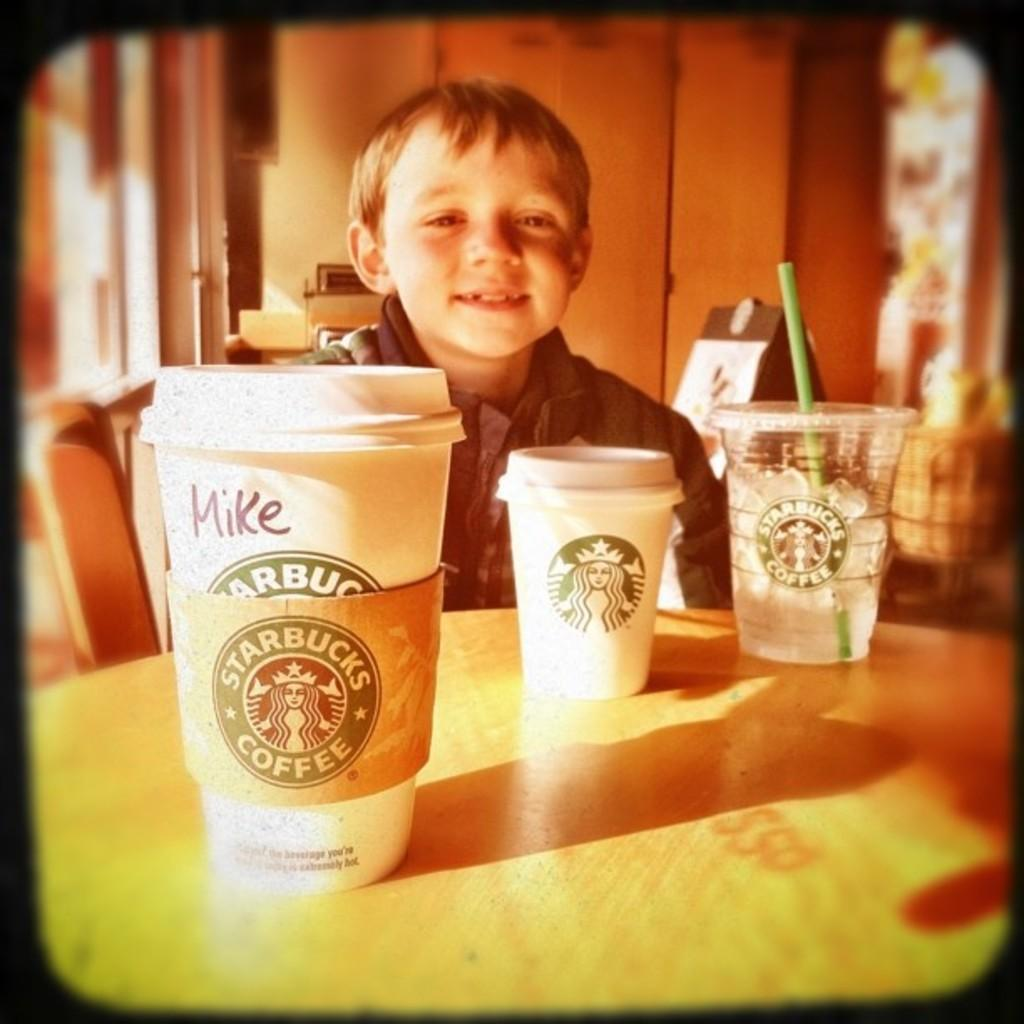Provide a one-sentence caption for the provided image. A child who may or may not be Mike sits at a table with three Starbucks beverages. 